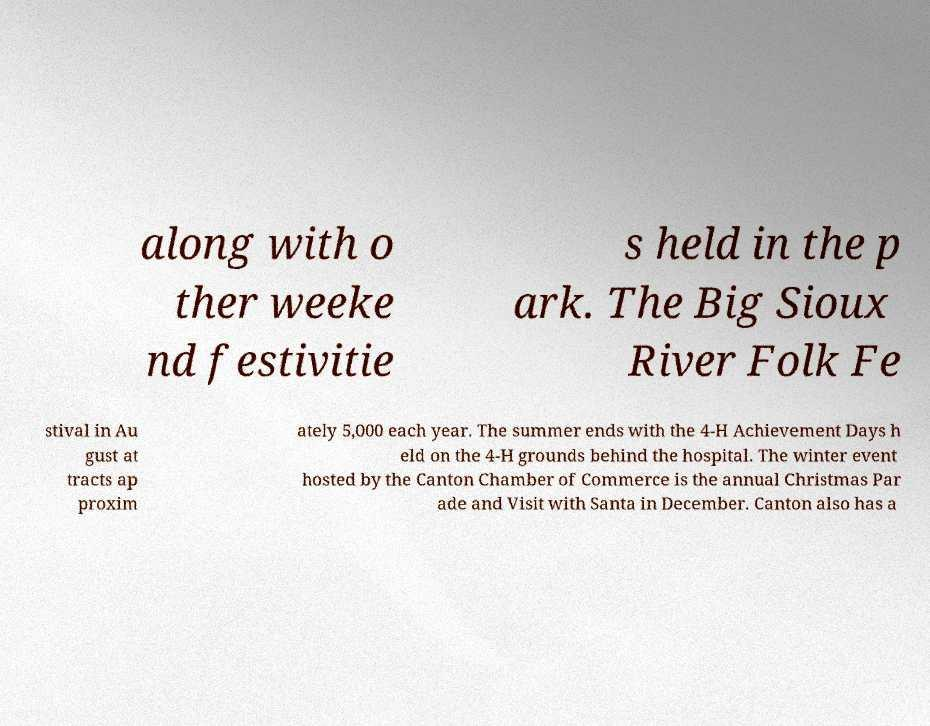Can you accurately transcribe the text from the provided image for me? along with o ther weeke nd festivitie s held in the p ark. The Big Sioux River Folk Fe stival in Au gust at tracts ap proxim ately 5,000 each year. The summer ends with the 4-H Achievement Days h eld on the 4-H grounds behind the hospital. The winter event hosted by the Canton Chamber of Commerce is the annual Christmas Par ade and Visit with Santa in December. Canton also has a 